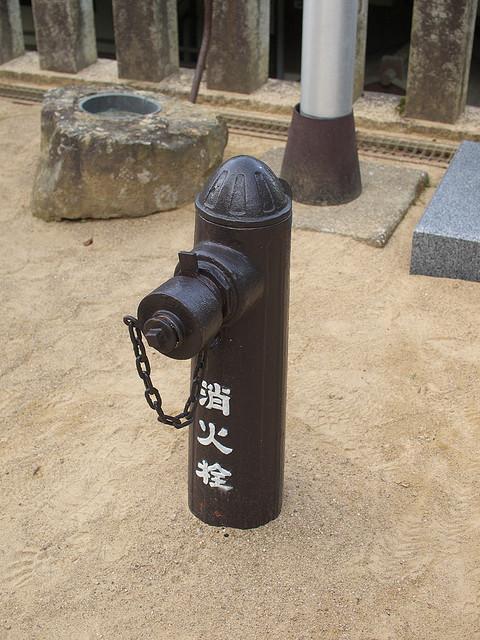How many fire hydrants are in the photo?
Give a very brief answer. 1. 